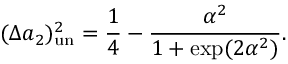<formula> <loc_0><loc_0><loc_500><loc_500>( \Delta a _ { 2 } ) _ { u n } ^ { 2 } = \frac { 1 } { 4 } - \frac { \alpha ^ { 2 } } { 1 + \exp ( 2 \alpha ^ { 2 } ) } .</formula> 